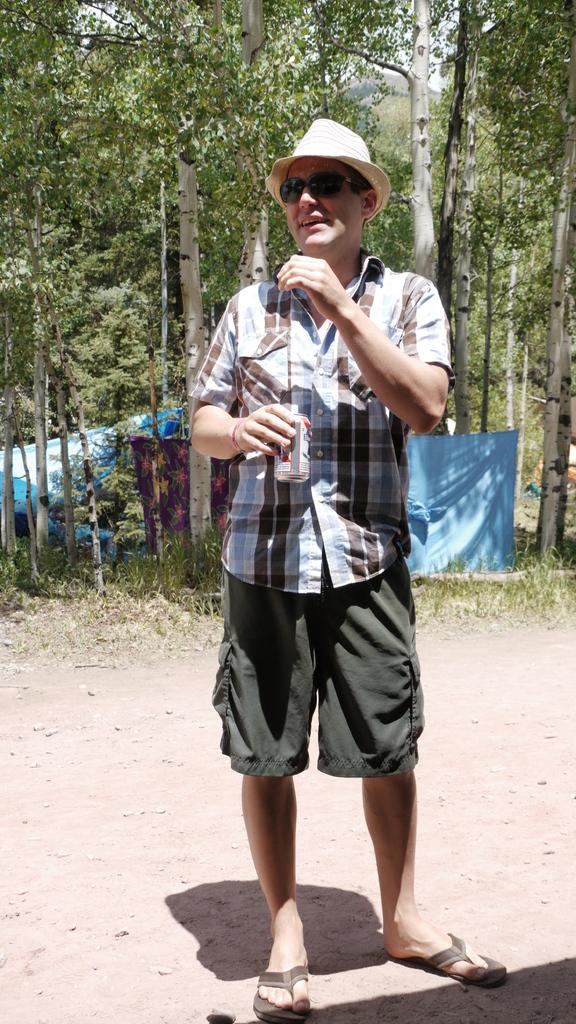What is the main subject of the image? There is a man standing in the image. What is the man standing on? The man is standing on land. Can you describe the man's appearance? The man is wearing spectacles and a green color hat. What can be seen in the background of the image? There are trees and a blue color cloth in the background of the image. What type of lettuce is being used as a lead weight in the image? There is no lettuce or lead weight present in the image. What type of school can be seen in the background of the image? There is no school visible in the image; only trees and a blue color cloth are present in the background. 